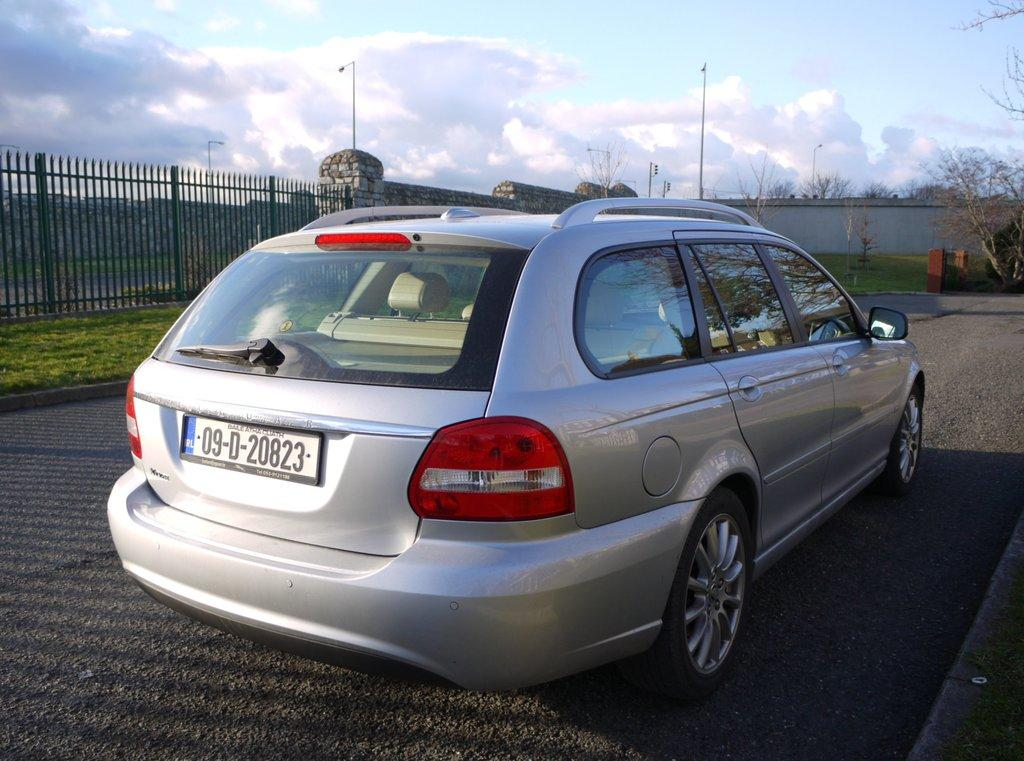What is the main subject of the image? There is a car on the road in the image. What type of natural environment can be seen in the image? There is grass, trees, and a sky visible in the image. What structures are present in the image? There is a fence, walls, and poles in the image. Can you describe the sky in the image? The sky is visible in the background of the image, and clouds are present. What are the unspecified objects in the image? Unfortunately, the facts provided do not specify the nature of these objects. What type of pollution can be seen coming from the car in the image? There is no indication of pollution in the image; the car appears to be stationary on the road. What thrilling action is taking place in the image? There is no thrilling action depicted in the image; it shows a car on the road, surrounded by natural elements and structures. 